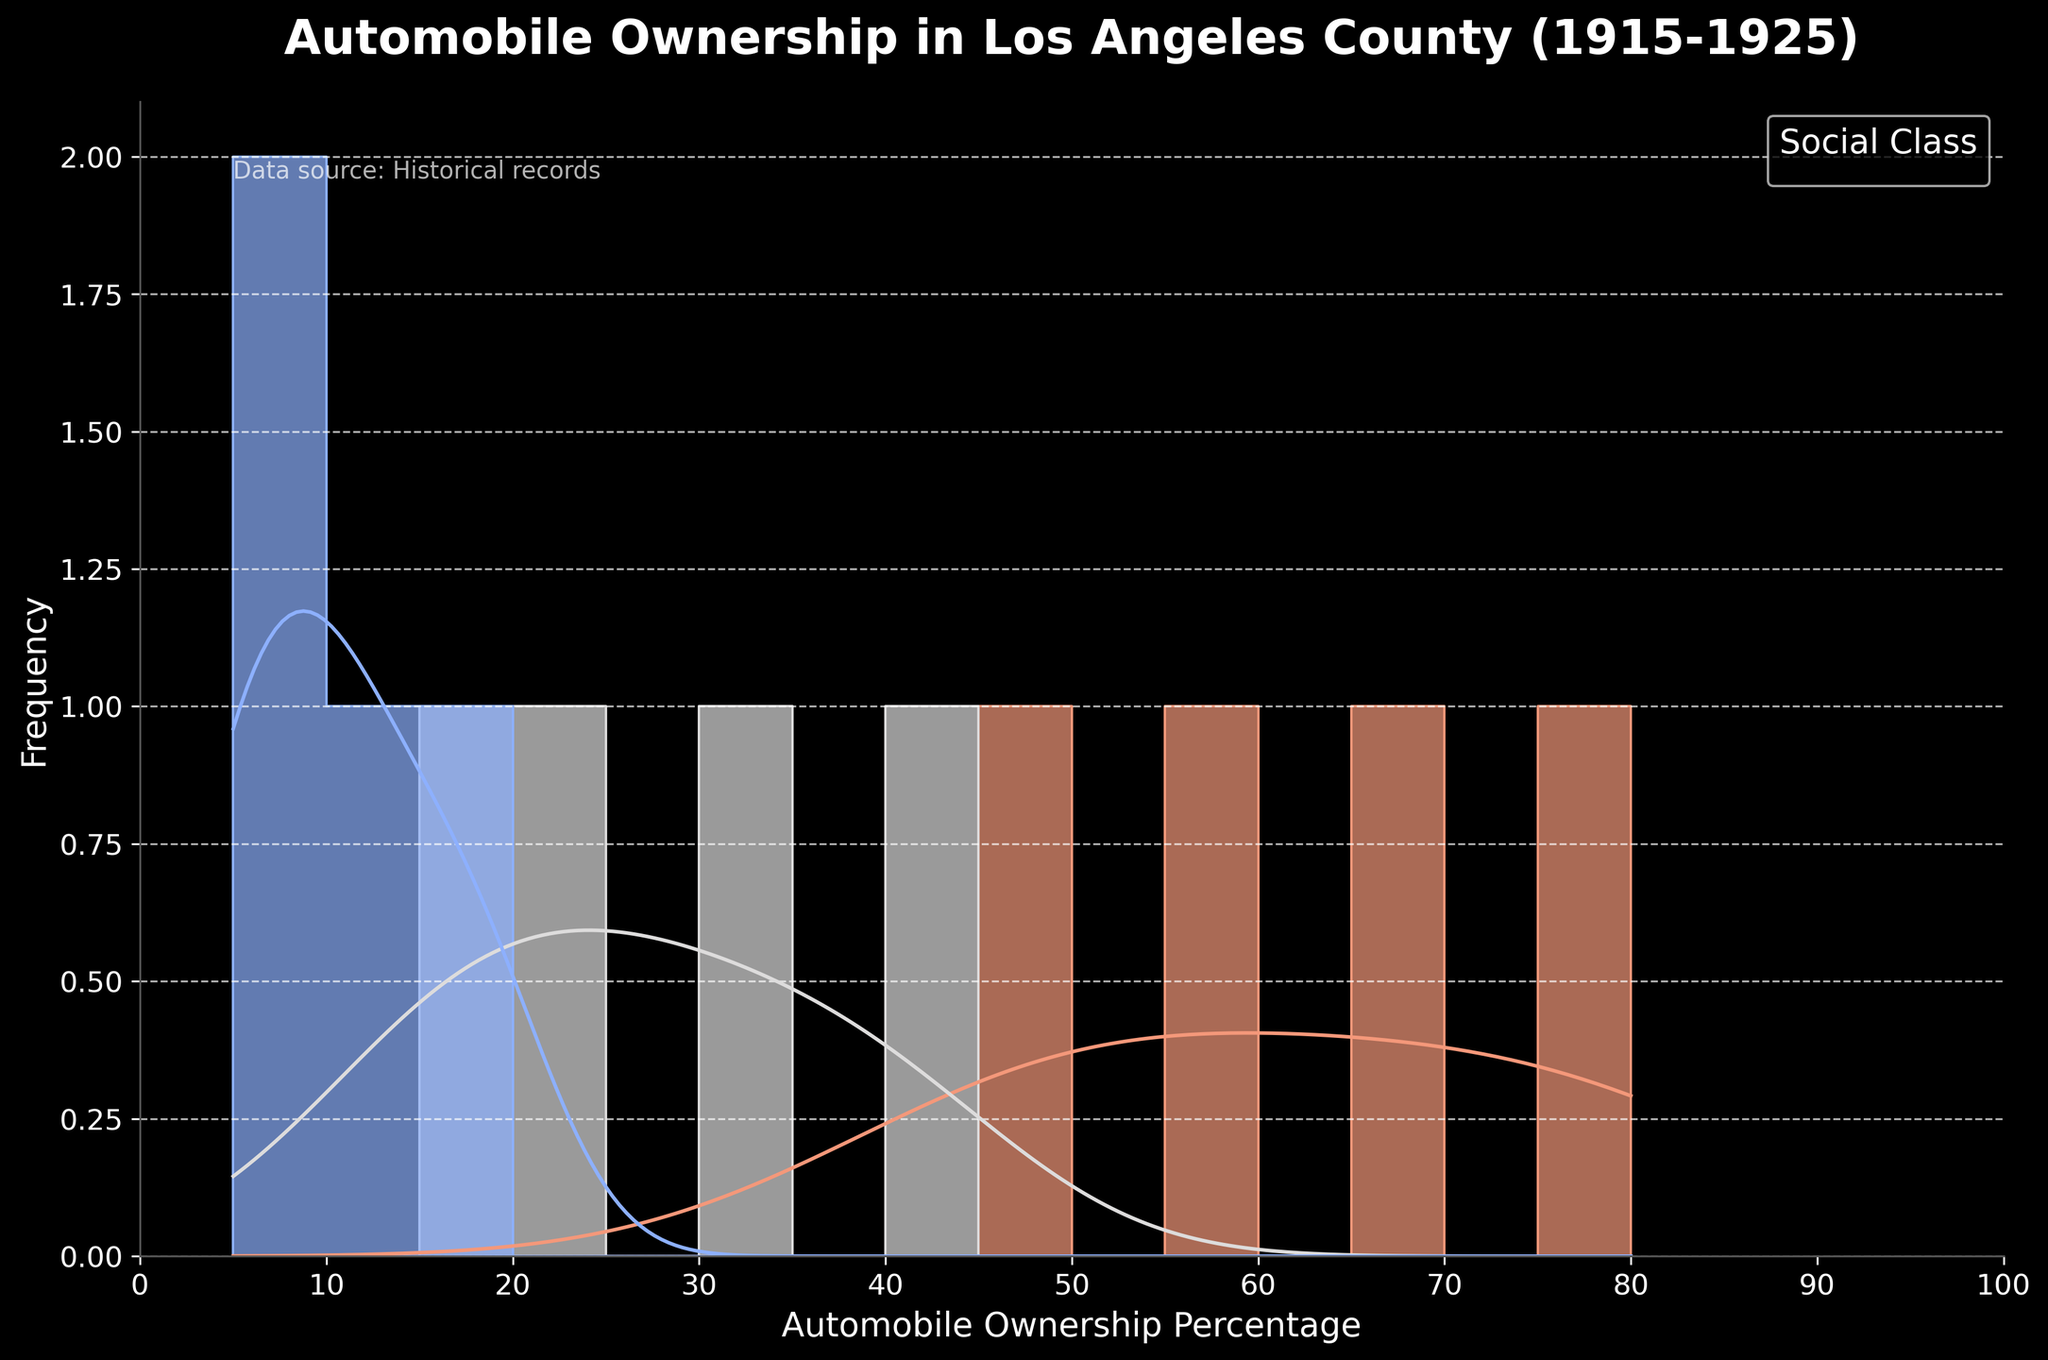What is the title of the plot? The title of the plot is clearly displayed at the top. It reads "Automobile Ownership in Los Angeles County (1915-1925)."
Answer: Automobile Ownership in Los Angeles County (1915-1925) What is the x-axis label in the plot? The x-axis label is shown directly below the x-axis line. It is labelled as "Automobile Ownership Percentage."
Answer: Automobile Ownership Percentage Which social class had the highest peak in automobile ownership percentage? Observing the peaks of the density curves, the Upper Class has the highest peak, indicating the highest automobile ownership percentage.
Answer: Upper Class Between which years did the Middle Class see the most significant increase in automobile ownership? By examining the data points and peaks of each class, we can see that the Middle Class shows the most significant jump between 1918 (22%) and 1921 (30%).
Answer: 1918 to 1921 How does the automobile ownership percentage of the Working Class in 1925 compare to that in 1915? Checking the individual data points, the Working Class went from 5% in 1915 to 18% in 1925, showing an increase.
Answer: Increased What is the highest automobile ownership percentage observed for the Middle Class across the years shown? The Middle Class in 1925 shows the highest percentage, which is 40% as per the histogram data.
Answer: 40% What is the overall trend in automobile ownership for the Upper Class from 1915 to 1925? The data points and density curves suggest a consistent increase in automobile ownership for the Upper Class from 45% in 1915 to 80% in 1925.
Answer: Increasing In which year did the Working Class have the lowest automobile ownership percentage, and what was that percentage? Referring to the data points, the Working Class had the lowest percentage in 1915, which was 5%.
Answer: 1915, 5% What can be inferred about the automobile ownership percentage of the Upper Class compared to the other classes in 1925? The Upper Class has an 80% ownership, significantly higher compared to the Middle Class (40%) and Working Class (18%), indicating substantial disparity.
Answer: Significantly higher What does the KDE (density curve) for the Working Class indicate about the variability in automobile ownership percentage? The KDE for the Working Class shows a broader and lower peak, indicating higher variability and more spread out ownership percentages across the years.
Answer: Higher variability 